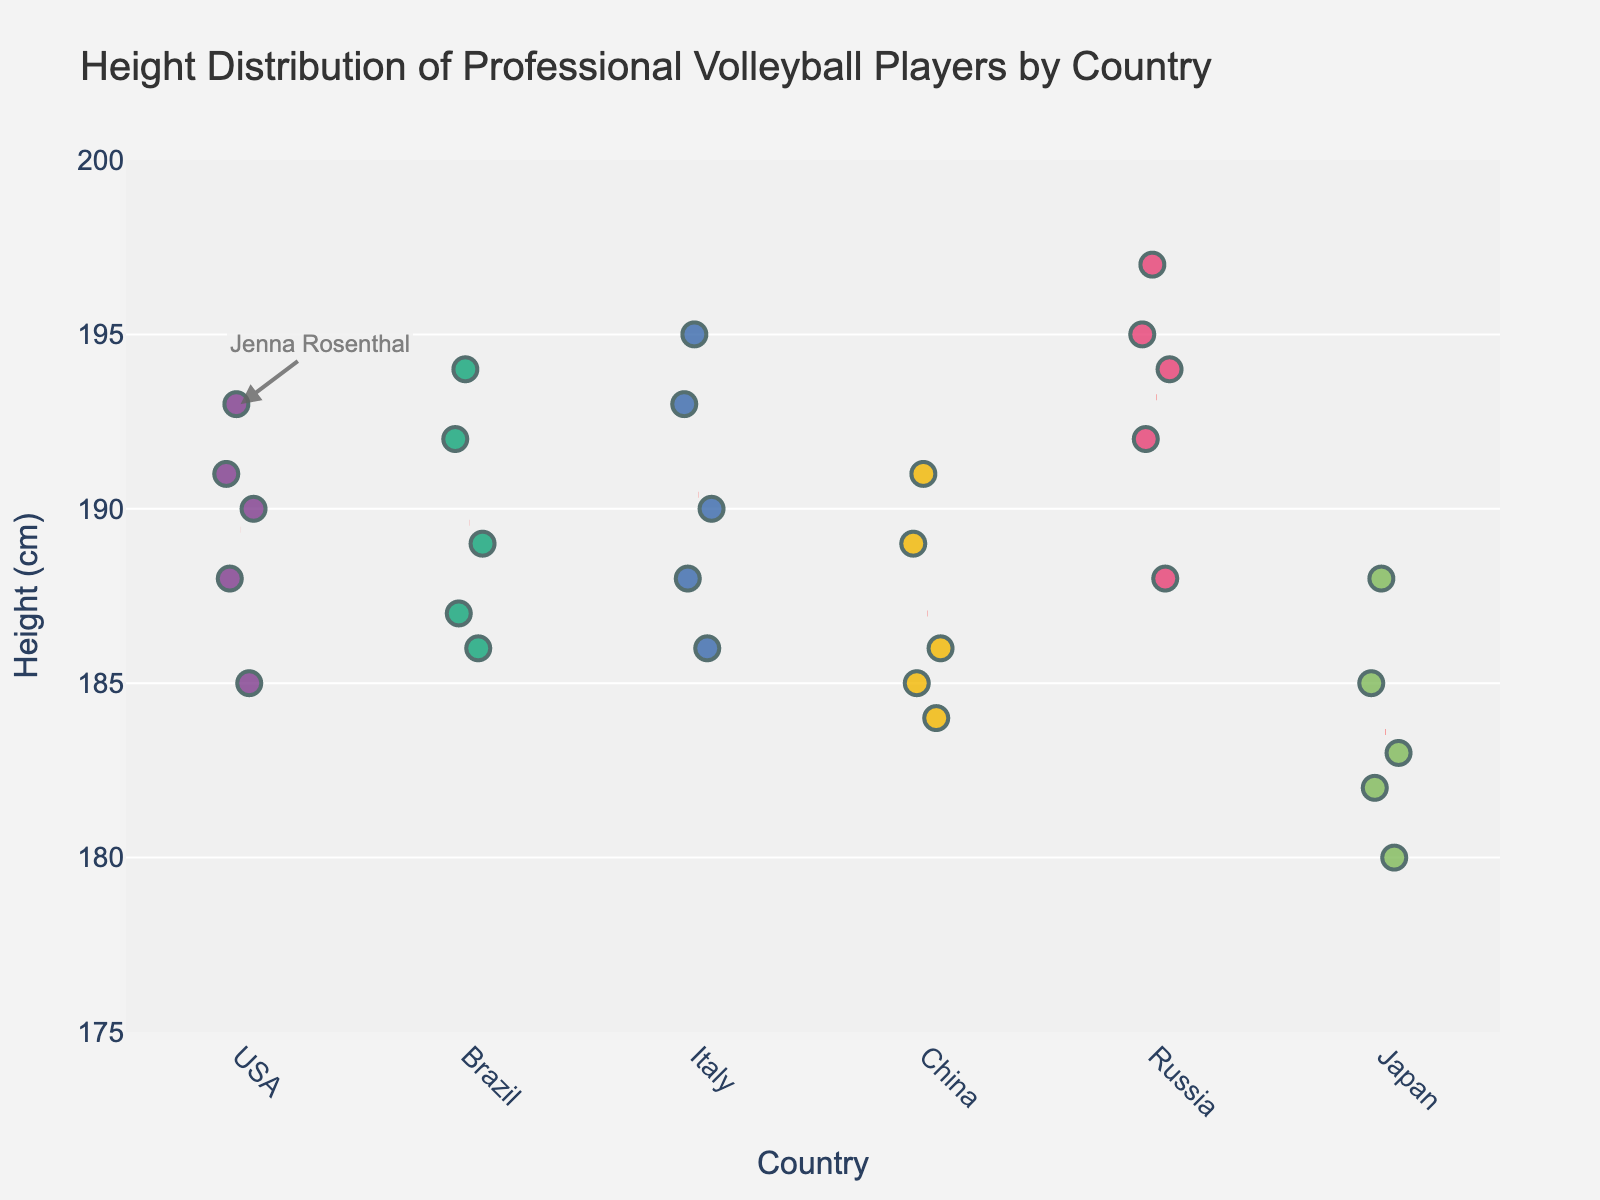What is the title of the plot? The title of the plot is displayed at the top and is usually the most noticeable text element, providing the main subject or purpose of the plot.
Answer: Height Distribution of Professional Volleyball Players by Country What is the range of heights displayed on the y-axis? The y-axis displays the height range of the volleyball players. By looking closely at the numbers marked on the y-axis, we can determine the range from the lowest to the highest value.
Answer: 175 to 200 cm How many players from Japan are included in the plot? Each country's players are represented by individual points under the respective country name on the x-axis. Count the number of points under "Japan". This involves counting 5 individual markers (dots).
Answer: 5 What color represents the players from Russia? The players from each country are represented by different colors. By identifying the color under the label "Russia" on the x-axis, we can determine this.
Answer: Blue What is the average height of the players from Brazil? Each point under "Brazil" represents the height of a player. Sum the heights (186, 194, 189, 192, 187) and divide by the number of players (5). Calculation: (186+194+189+192+187)/5 = 189.6
Answer: 189.6 cm Which country has the player with the tallest height? Compare the highest points (tallest players) for each country and identify which country's point reaches the highest on the y-axis. The tallest height noted is 197 cm for Russia.
Answer: Russia Is Jenna Rosenthal's height above or below the average height of players from the USA? Jenna Rosenthal's height is marked with an annotation at 193 cm. Calculate the average height of USA players (193, 188, 191, 185, 190): (193+188+191+185+190)/5 = 189.4. Compare 193 to this average.
Answer: Above How do the height distributions of Chinese players compare to Italian players? Compare the spread of points under "China" and "Italy" on the x-axis. Note the clustering and range for each country. The Chinese players are between 184 and 191 cm, while Italian players range from 186 to 195 cm.
Answer: Italian players show a broader range Which two countries have the closest average heights? Calculate the average heights for all countries and compare: USA (189.4), Brazil (189.6), Italy (190.4), China (187.0), Russia (193.2), Japan (183.6). USA and Brazil have the closest averages with 189.4 and 189.6.
Answer: USA and Brazil 